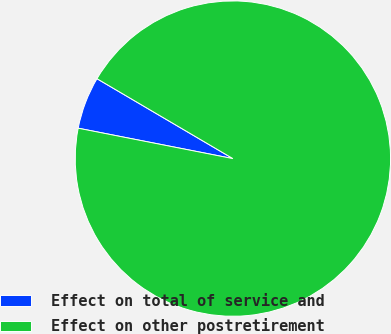Convert chart to OTSL. <chart><loc_0><loc_0><loc_500><loc_500><pie_chart><fcel>Effect on total of service and<fcel>Effect on other postretirement<nl><fcel>5.37%<fcel>94.63%<nl></chart> 